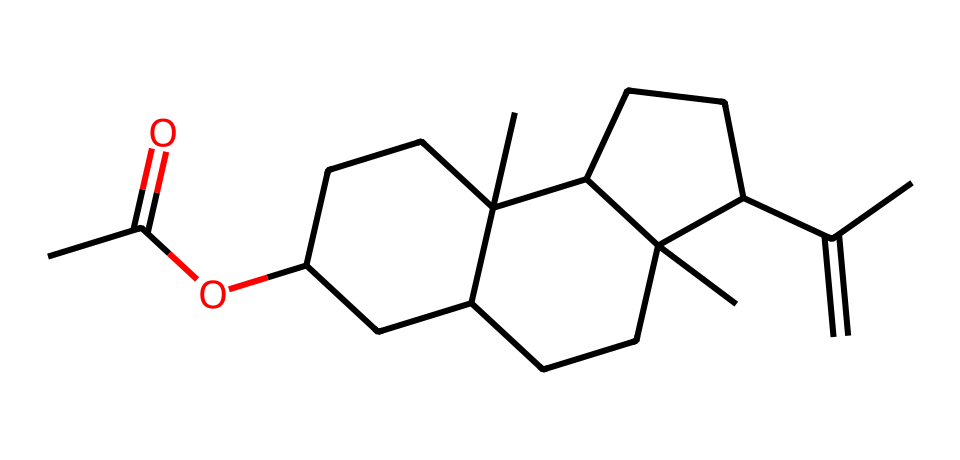What is the functional group present in this chemical? The SMILES representation indicates an ester group, which is characterized by the presence of a carbonyl (C=O) attached to an oxygen (O) that is also connected to another carbon chain. The presence of "CC(=O)O" at the beginning of the structure highlights the ester functional group.
Answer: ester How many carbon atoms are in the structure? By analyzing the SMILES representation, we can count the number of carbon atoms directly: each carbon symbol "C" counts towards the total. The specific arrangement shows a total of 15 carbon atoms.
Answer: 15 What type of bond connects the carbonyl and the oxygen in the ester group? The connection between the carbonyl carbon and the oxygen in the ester group is a single bond, as no double bond is indicated in the given section of the SMILES for that part, maintaining it as a functional connector for the carbon backbone.
Answer: single bond What is the longest carbon chain present in this structure? The chemical structure indicates several cyclic and acyclic components, but the longest continuous chain can be observed by following the carbon atoms connected directly without interruptions by branching. The longest carbon chain here is a 10-carbon ring structure with additional branches.
Answer: 10 What indicates the presence of cycloalkanes in this molecule? The presence of rings can be inferred from the numeric indicators in the SMILES representation that denote the start and end of rings. Specifically, the "C1" and "C2" indicate bridging points forming cycles, confirming that this compound contains cycloalkanes.
Answer: cycloalkanes What is the primary application of such encapsulated fragrance molecules? Encapsulated fragrance molecules are primarily used in scented products to provide sustained aroma release over time, effectively extending the duration of fragrance in candles and similar products.
Answer: scent retention What property does the structure of this molecule impart to its fragrance profile? The intricate structure with multiple carbon chains contributes to the overall volatility and interaction with air, playing a key role in the molecule's ability to slowly release its scent, leading to a long-lasting fragrance.
Answer: longevity 